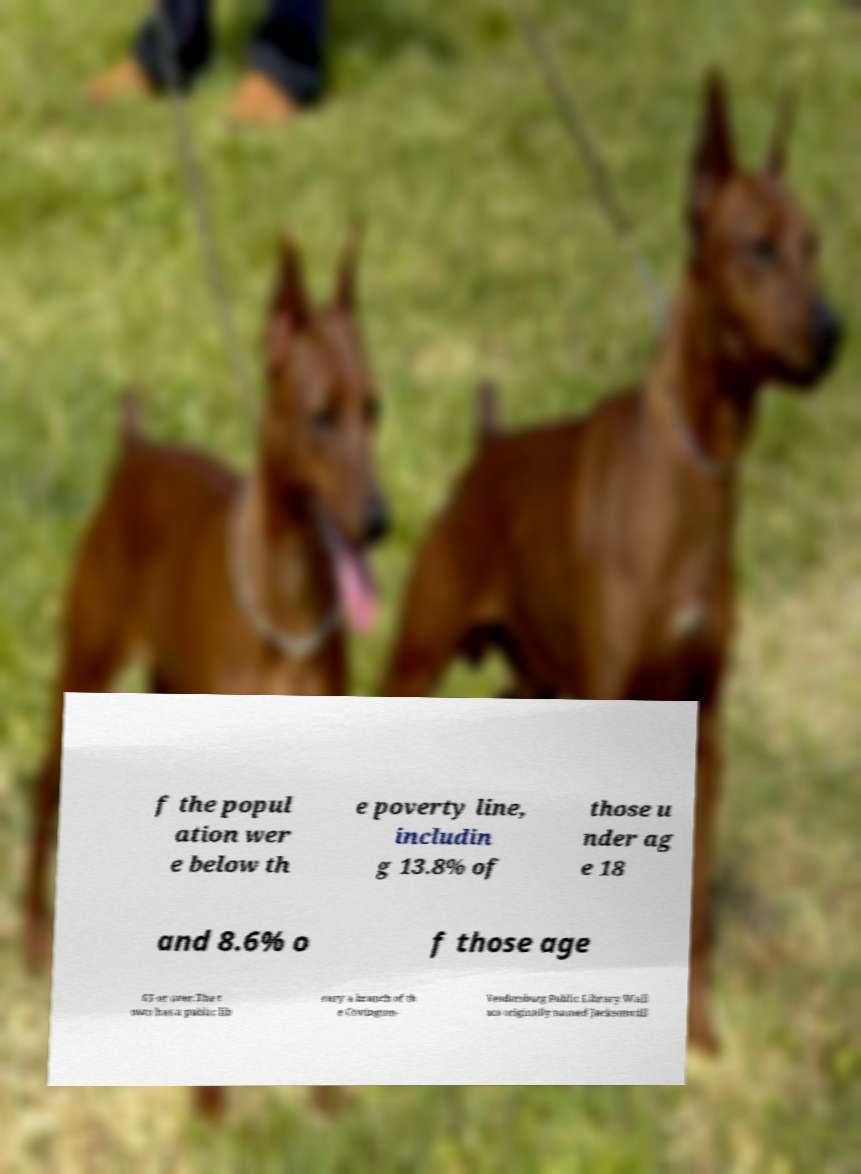Could you extract and type out the text from this image? f the popul ation wer e below th e poverty line, includin g 13.8% of those u nder ag e 18 and 8.6% o f those age 65 or over.The t own has a public lib rary a branch of th e Covington- Veedersburg Public Library.Wall ace originally named Jacksonvill 